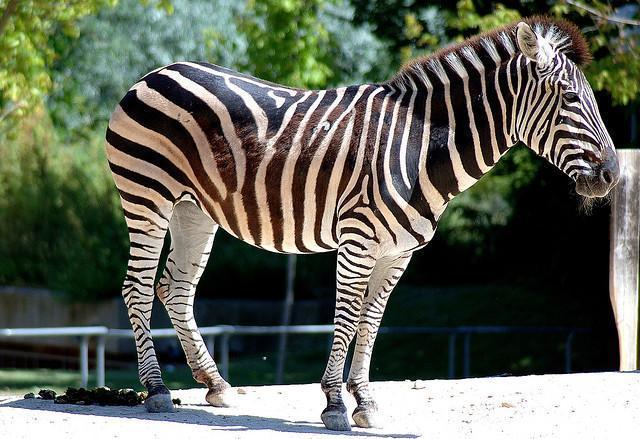How many people are there wearing black shirts?
Give a very brief answer. 0. 